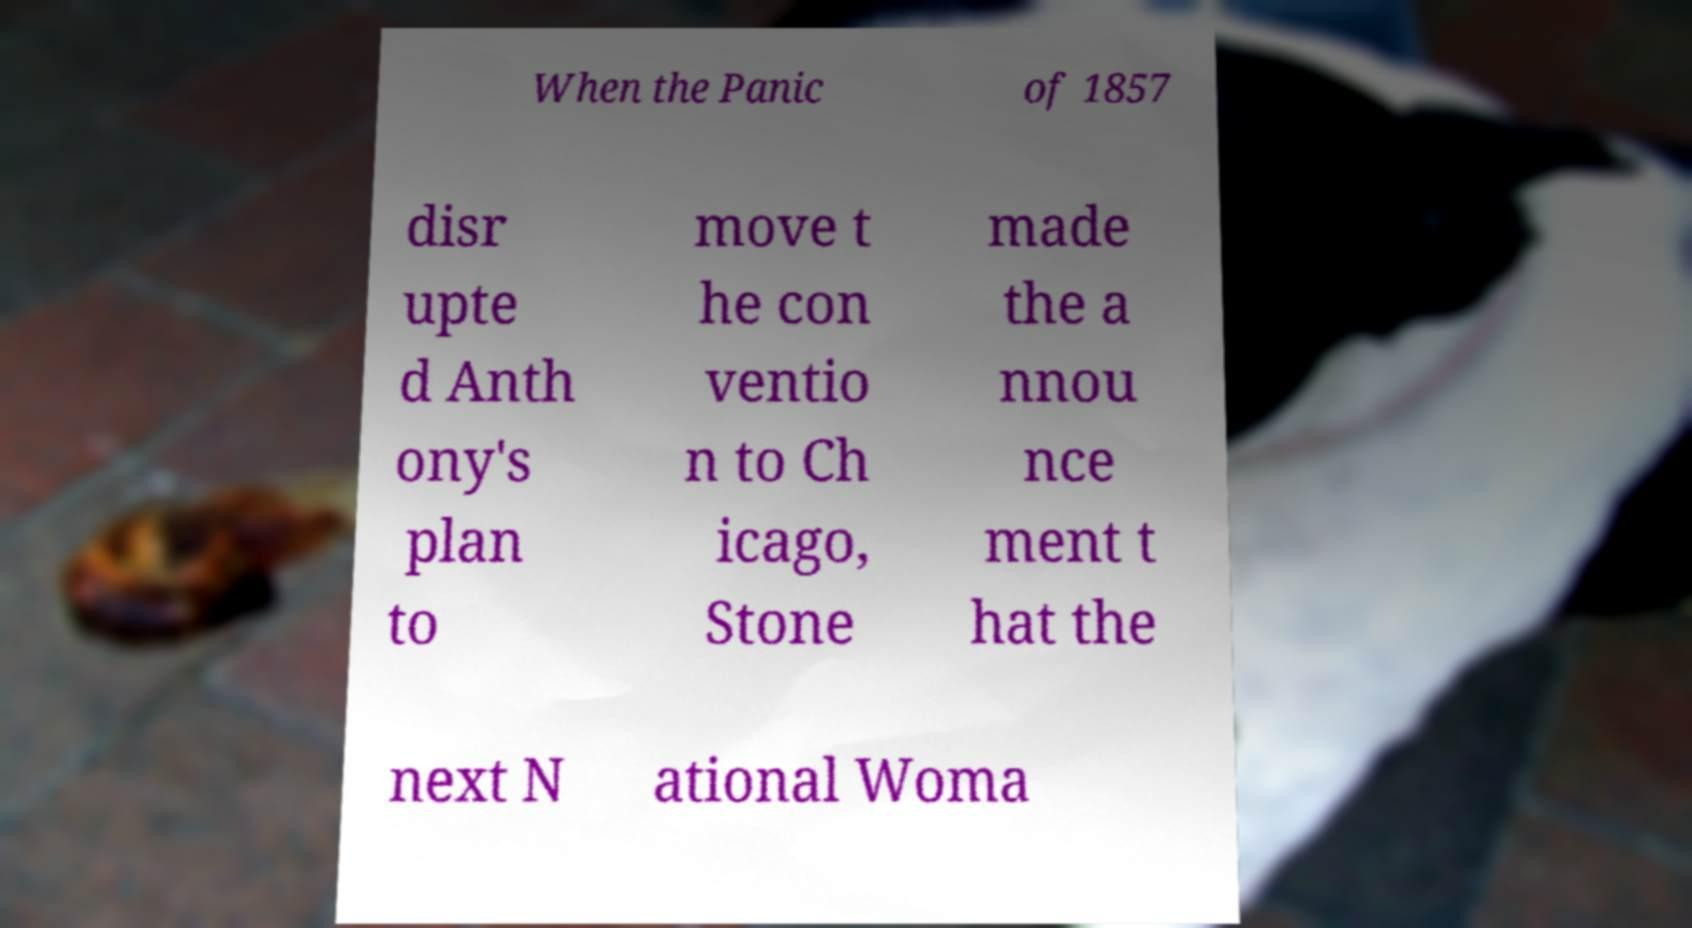Could you extract and type out the text from this image? When the Panic of 1857 disr upte d Anth ony's plan to move t he con ventio n to Ch icago, Stone made the a nnou nce ment t hat the next N ational Woma 